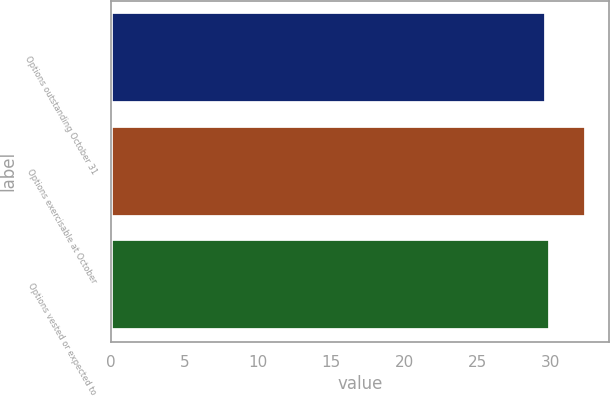Convert chart. <chart><loc_0><loc_0><loc_500><loc_500><bar_chart><fcel>Options outstanding October 31<fcel>Options exercisable at October<fcel>Options vested or expected to<nl><fcel>29.71<fcel>32.39<fcel>29.98<nl></chart> 